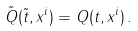Convert formula to latex. <formula><loc_0><loc_0><loc_500><loc_500>\tilde { Q } ( \tilde { t } , x ^ { i } ) = Q ( t , x ^ { i } ) \, .</formula> 